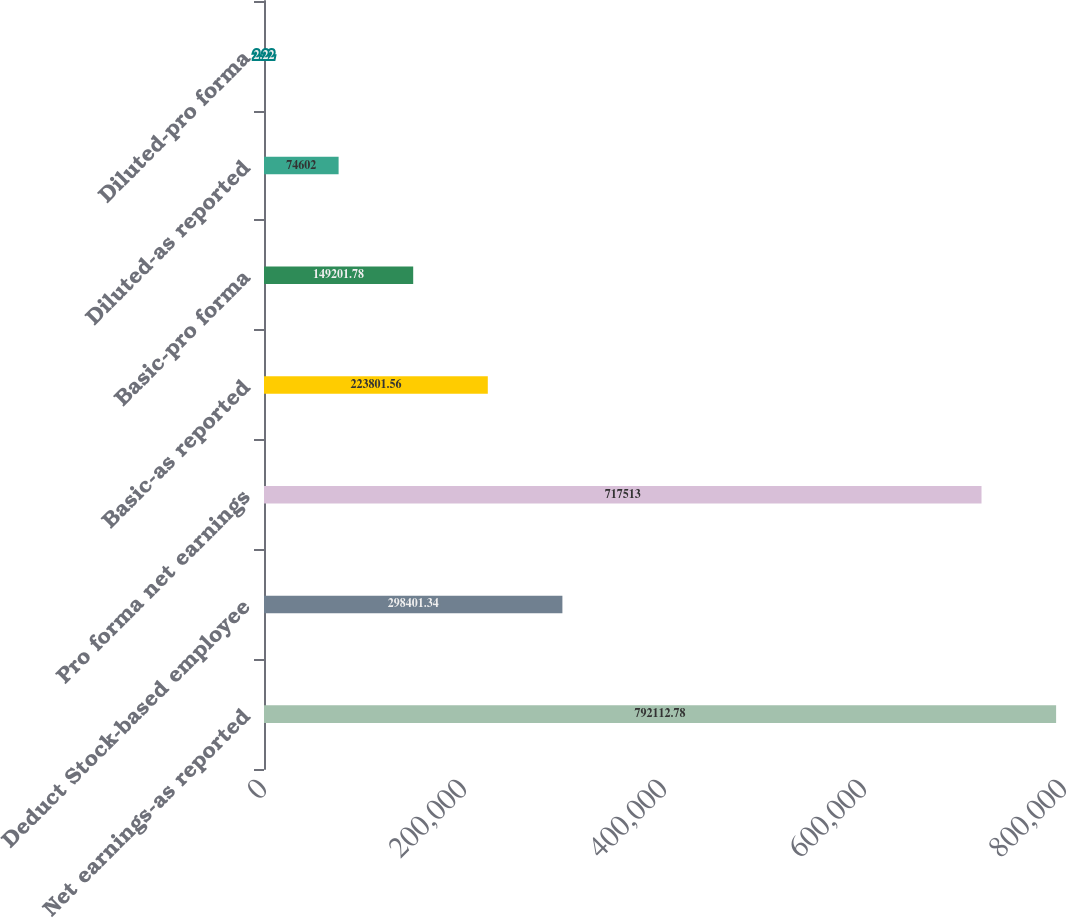Convert chart to OTSL. <chart><loc_0><loc_0><loc_500><loc_500><bar_chart><fcel>Net earnings-as reported<fcel>Deduct Stock-based employee<fcel>Pro forma net earnings<fcel>Basic-as reported<fcel>Basic-pro forma<fcel>Diluted-as reported<fcel>Diluted-pro forma<nl><fcel>792113<fcel>298401<fcel>717513<fcel>223802<fcel>149202<fcel>74602<fcel>2.22<nl></chart> 